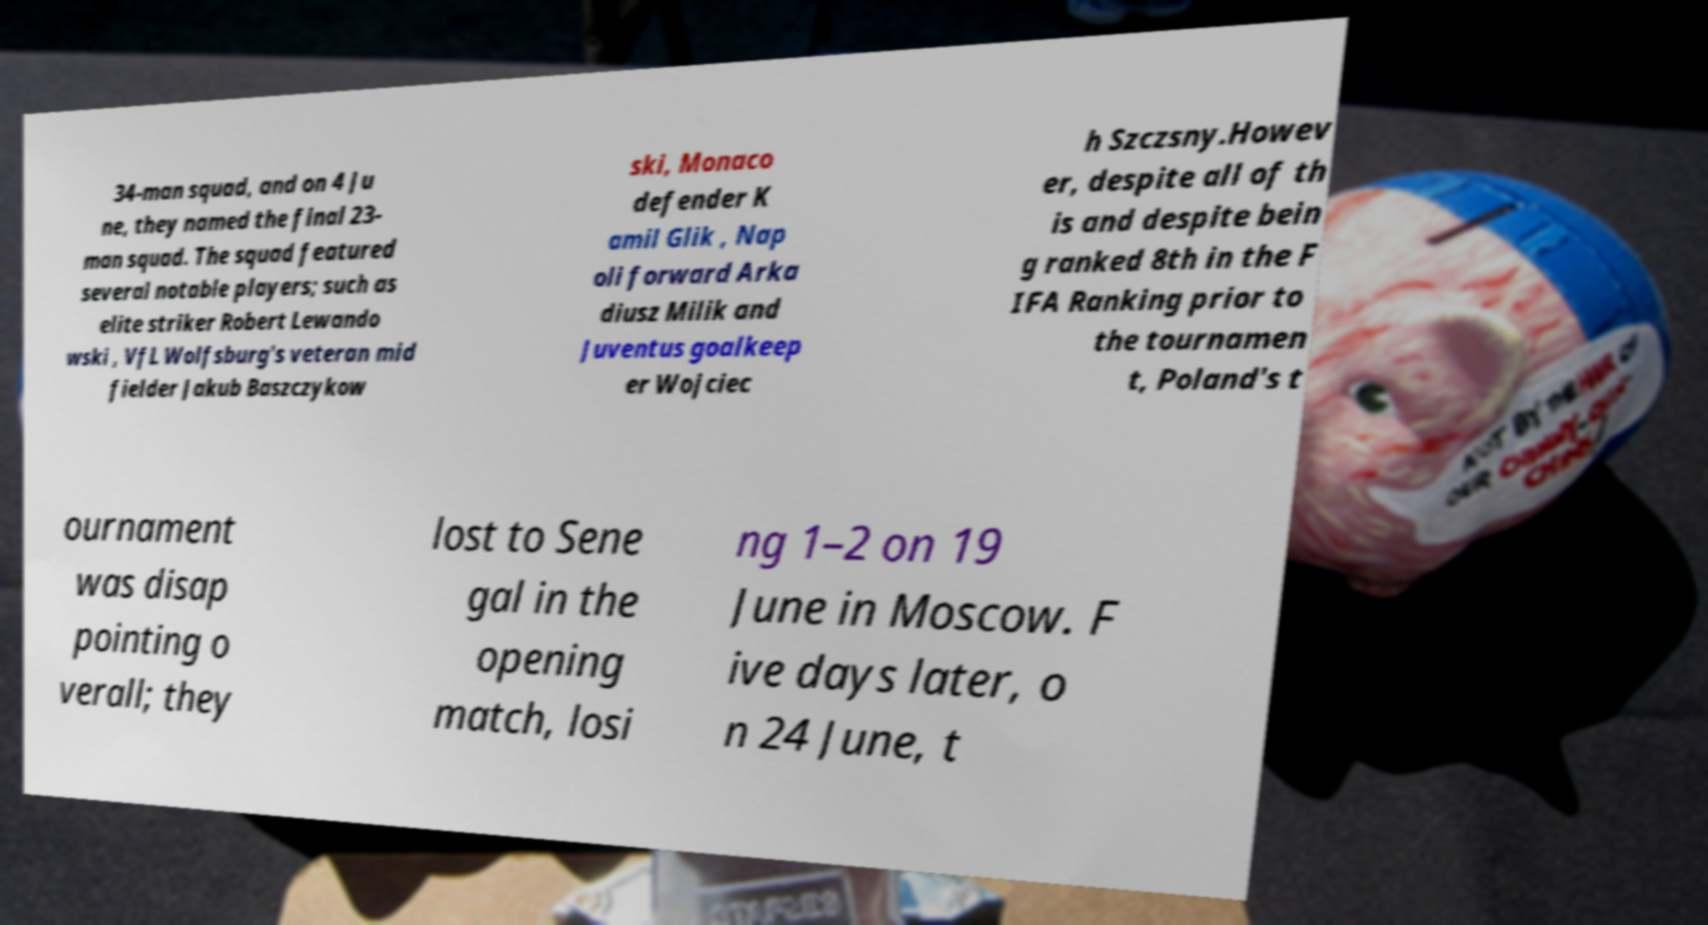What messages or text are displayed in this image? I need them in a readable, typed format. 34-man squad, and on 4 Ju ne, they named the final 23- man squad. The squad featured several notable players; such as elite striker Robert Lewando wski , VfL Wolfsburg's veteran mid fielder Jakub Baszczykow ski, Monaco defender K amil Glik , Nap oli forward Arka diusz Milik and Juventus goalkeep er Wojciec h Szczsny.Howev er, despite all of th is and despite bein g ranked 8th in the F IFA Ranking prior to the tournamen t, Poland's t ournament was disap pointing o verall; they lost to Sene gal in the opening match, losi ng 1–2 on 19 June in Moscow. F ive days later, o n 24 June, t 